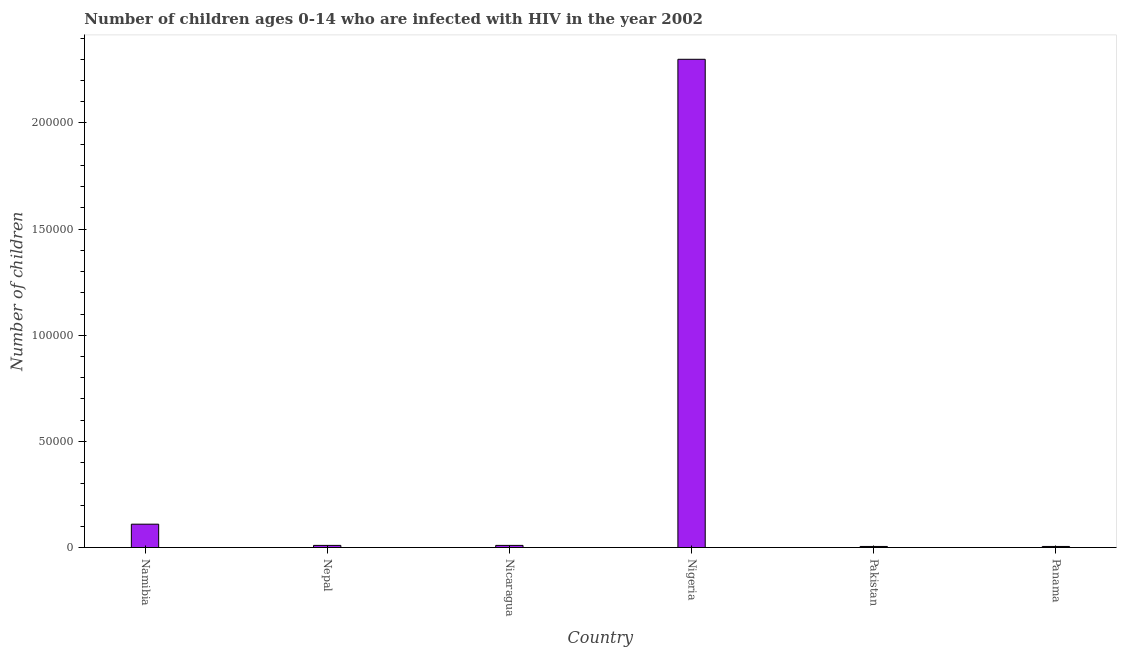What is the title of the graph?
Offer a terse response. Number of children ages 0-14 who are infected with HIV in the year 2002. What is the label or title of the Y-axis?
Offer a very short reply. Number of children. Across all countries, what is the minimum number of children living with hiv?
Provide a succinct answer. 500. In which country was the number of children living with hiv maximum?
Offer a very short reply. Nigeria. In which country was the number of children living with hiv minimum?
Keep it short and to the point. Pakistan. What is the sum of the number of children living with hiv?
Make the answer very short. 2.44e+05. What is the difference between the number of children living with hiv in Nicaragua and Pakistan?
Ensure brevity in your answer.  500. What is the average number of children living with hiv per country?
Provide a short and direct response. 4.07e+04. In how many countries, is the number of children living with hiv greater than 140000 ?
Your answer should be compact. 1. What is the ratio of the number of children living with hiv in Namibia to that in Panama?
Offer a very short reply. 22. Is the number of children living with hiv in Nepal less than that in Pakistan?
Your answer should be very brief. No. What is the difference between the highest and the second highest number of children living with hiv?
Your response must be concise. 2.19e+05. What is the difference between the highest and the lowest number of children living with hiv?
Make the answer very short. 2.30e+05. Are all the bars in the graph horizontal?
Provide a short and direct response. No. What is the Number of children in Namibia?
Ensure brevity in your answer.  1.10e+04. What is the Number of children of Nigeria?
Your response must be concise. 2.30e+05. What is the Number of children in Pakistan?
Give a very brief answer. 500. What is the difference between the Number of children in Namibia and Nicaragua?
Provide a short and direct response. 10000. What is the difference between the Number of children in Namibia and Nigeria?
Keep it short and to the point. -2.19e+05. What is the difference between the Number of children in Namibia and Pakistan?
Ensure brevity in your answer.  1.05e+04. What is the difference between the Number of children in Namibia and Panama?
Ensure brevity in your answer.  1.05e+04. What is the difference between the Number of children in Nepal and Nicaragua?
Offer a very short reply. 0. What is the difference between the Number of children in Nepal and Nigeria?
Give a very brief answer. -2.29e+05. What is the difference between the Number of children in Nepal and Panama?
Offer a very short reply. 500. What is the difference between the Number of children in Nicaragua and Nigeria?
Provide a succinct answer. -2.29e+05. What is the difference between the Number of children in Nicaragua and Panama?
Your response must be concise. 500. What is the difference between the Number of children in Nigeria and Pakistan?
Give a very brief answer. 2.30e+05. What is the difference between the Number of children in Nigeria and Panama?
Make the answer very short. 2.30e+05. What is the difference between the Number of children in Pakistan and Panama?
Provide a succinct answer. 0. What is the ratio of the Number of children in Namibia to that in Nicaragua?
Ensure brevity in your answer.  11. What is the ratio of the Number of children in Namibia to that in Nigeria?
Give a very brief answer. 0.05. What is the ratio of the Number of children in Nepal to that in Nigeria?
Keep it short and to the point. 0. What is the ratio of the Number of children in Nepal to that in Pakistan?
Make the answer very short. 2. What is the ratio of the Number of children in Nepal to that in Panama?
Keep it short and to the point. 2. What is the ratio of the Number of children in Nicaragua to that in Nigeria?
Offer a very short reply. 0. What is the ratio of the Number of children in Nicaragua to that in Panama?
Your answer should be very brief. 2. What is the ratio of the Number of children in Nigeria to that in Pakistan?
Offer a very short reply. 460. What is the ratio of the Number of children in Nigeria to that in Panama?
Your answer should be compact. 460. 